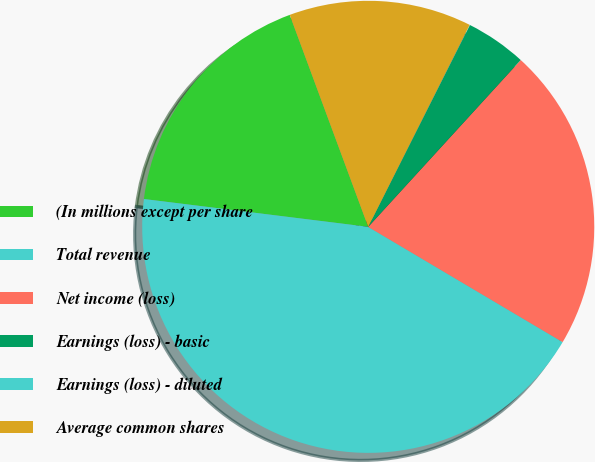Convert chart. <chart><loc_0><loc_0><loc_500><loc_500><pie_chart><fcel>(In millions except per share<fcel>Total revenue<fcel>Net income (loss)<fcel>Earnings (loss) - basic<fcel>Earnings (loss) - diluted<fcel>Average common shares<nl><fcel>17.39%<fcel>43.45%<fcel>21.73%<fcel>4.36%<fcel>0.02%<fcel>13.05%<nl></chart> 